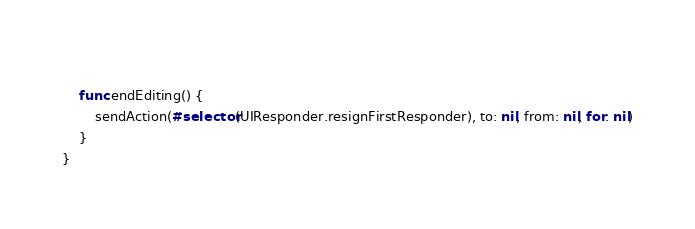Convert code to text. <code><loc_0><loc_0><loc_500><loc_500><_Swift_>    
    func endEditing() {
        sendAction(#selector(UIResponder.resignFirstResponder), to: nil, from: nil, for: nil)
    }
}
</code> 